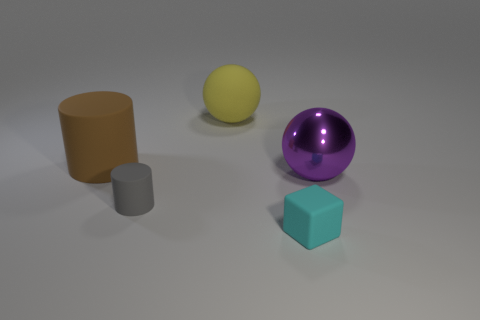What could be the context or use of this arrangement of objects? This setup is reminiscent of a 3D modeling test scene where various shapes and materials are used to demonstrate rendering techniques like shading, reflection, and texture. How might the different surfaces of these objects affect their appearance in this image? The matte surfaces, like the one on the brown and gray cylinders, absorb more light, giving them a flatter appearance. Conversely, the purple sphere has a reflective surface that catches and bounces light, creating highlights and mirrored images of the environment, which adds visual interest and complexity to the scene. 